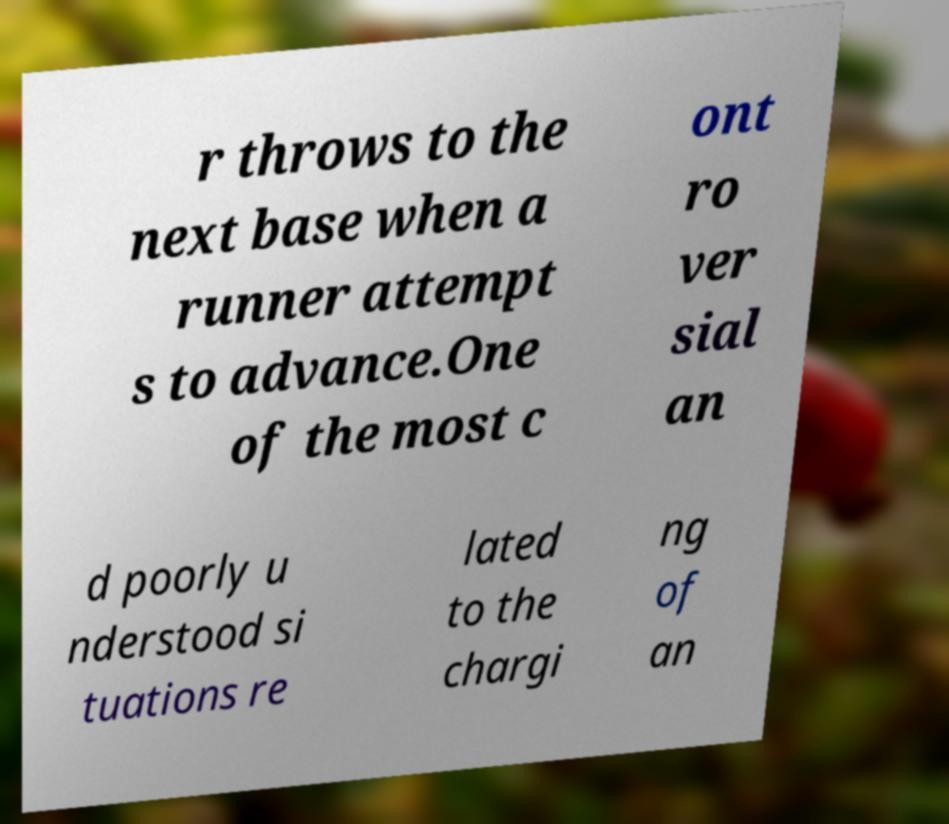Can you accurately transcribe the text from the provided image for me? r throws to the next base when a runner attempt s to advance.One of the most c ont ro ver sial an d poorly u nderstood si tuations re lated to the chargi ng of an 